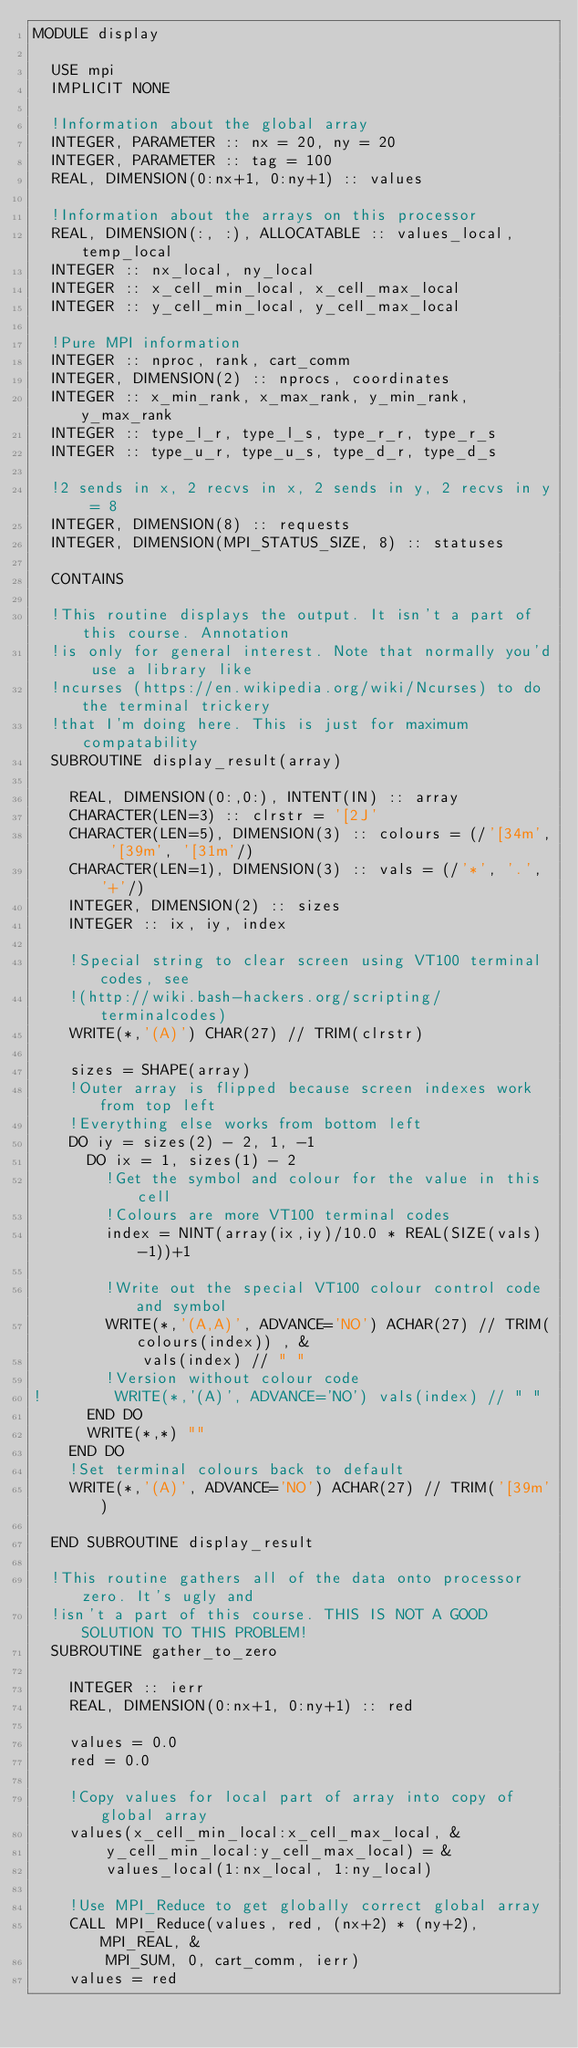Convert code to text. <code><loc_0><loc_0><loc_500><loc_500><_FORTRAN_>MODULE display

  USE mpi
  IMPLICIT NONE

  !Information about the global array
  INTEGER, PARAMETER :: nx = 20, ny = 20
  INTEGER, PARAMETER :: tag = 100
  REAL, DIMENSION(0:nx+1, 0:ny+1) :: values

  !Information about the arrays on this processor
  REAL, DIMENSION(:, :), ALLOCATABLE :: values_local, temp_local
  INTEGER :: nx_local, ny_local
  INTEGER :: x_cell_min_local, x_cell_max_local
  INTEGER :: y_cell_min_local, y_cell_max_local

  !Pure MPI information
  INTEGER :: nproc, rank, cart_comm
  INTEGER, DIMENSION(2) :: nprocs, coordinates
  INTEGER :: x_min_rank, x_max_rank, y_min_rank, y_max_rank
  INTEGER :: type_l_r, type_l_s, type_r_r, type_r_s
  INTEGER :: type_u_r, type_u_s, type_d_r, type_d_s

  !2 sends in x, 2 recvs in x, 2 sends in y, 2 recvs in y = 8
  INTEGER, DIMENSION(8) :: requests
  INTEGER, DIMENSION(MPI_STATUS_SIZE, 8) :: statuses

  CONTAINS

  !This routine displays the output. It isn't a part of this course. Annotation
  !is only for general interest. Note that normally you'd use a library like
  !ncurses (https://en.wikipedia.org/wiki/Ncurses) to do the terminal trickery
  !that I'm doing here. This is just for maximum compatability
  SUBROUTINE display_result(array)

    REAL, DIMENSION(0:,0:), INTENT(IN) :: array
    CHARACTER(LEN=3) :: clrstr = '[2J'
    CHARACTER(LEN=5), DIMENSION(3) :: colours = (/'[34m', '[39m', '[31m'/)
    CHARACTER(LEN=1), DIMENSION(3) :: vals = (/'*', '.', '+'/)
    INTEGER, DIMENSION(2) :: sizes
    INTEGER :: ix, iy, index

    !Special string to clear screen using VT100 terminal codes, see
    !(http://wiki.bash-hackers.org/scripting/terminalcodes)
    WRITE(*,'(A)') CHAR(27) // TRIM(clrstr)

    sizes = SHAPE(array)
    !Outer array is flipped because screen indexes work from top left
    !Everything else works from bottom left
    DO iy = sizes(2) - 2, 1, -1
      DO ix = 1, sizes(1) - 2
        !Get the symbol and colour for the value in this cell
        !Colours are more VT100 terminal codes
        index = NINT(array(ix,iy)/10.0 * REAL(SIZE(vals)-1))+1

        !Write out the special VT100 colour control code and symbol
        WRITE(*,'(A,A)', ADVANCE='NO') ACHAR(27) // TRIM(colours(index)) , &
            vals(index) // " "
        !Version without colour code
!        WRITE(*,'(A)', ADVANCE='NO') vals(index) // " "
      END DO
      WRITE(*,*) ""
    END DO
    !Set terminal colours back to default
    WRITE(*,'(A)', ADVANCE='NO') ACHAR(27) // TRIM('[39m')

  END SUBROUTINE display_result

  !This routine gathers all of the data onto processor zero. It's ugly and
  !isn't a part of this course. THIS IS NOT A GOOD SOLUTION TO THIS PROBLEM!
  SUBROUTINE gather_to_zero

    INTEGER :: ierr
    REAL, DIMENSION(0:nx+1, 0:ny+1) :: red

    values = 0.0
    red = 0.0

    !Copy values for local part of array into copy of global array
    values(x_cell_min_local:x_cell_max_local, &
        y_cell_min_local:y_cell_max_local) = &
        values_local(1:nx_local, 1:ny_local)

    !Use MPI_Reduce to get globally correct global array
    CALL MPI_Reduce(values, red, (nx+2) * (ny+2), MPI_REAL, &
        MPI_SUM, 0, cart_comm, ierr)
    values = red
</code> 